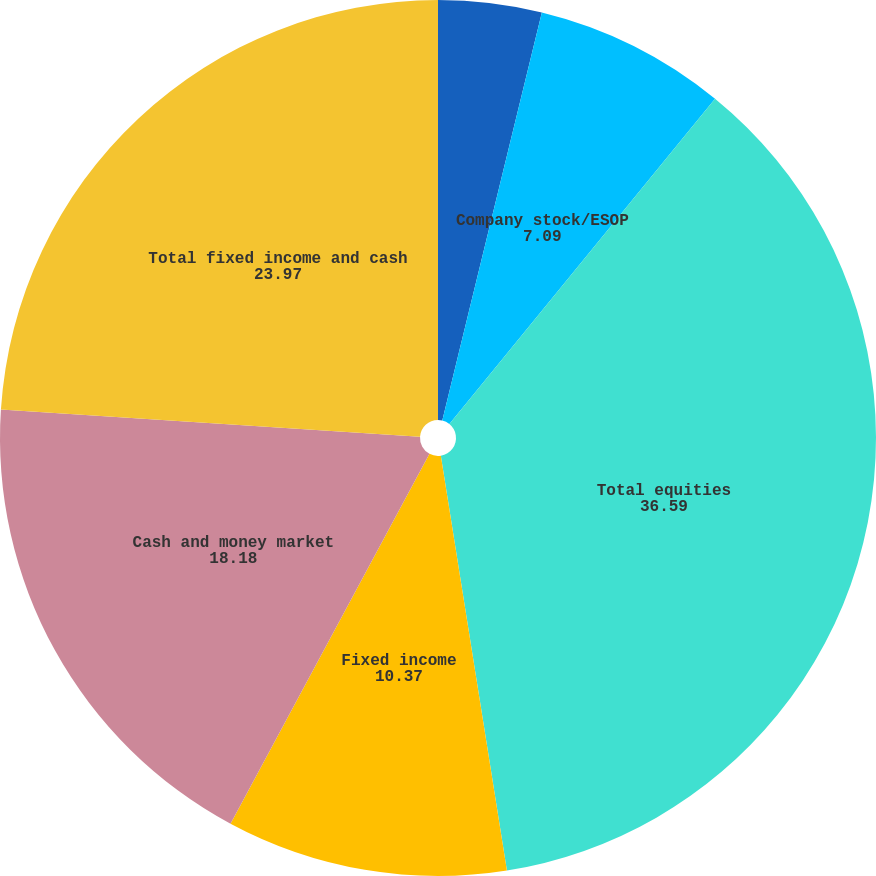<chart> <loc_0><loc_0><loc_500><loc_500><pie_chart><fcel>Active and other<fcel>Company stock/ESOP<fcel>Total equities<fcel>Fixed income<fcel>Cash and money market<fcel>Total fixed income and cash<nl><fcel>3.81%<fcel>7.09%<fcel>36.59%<fcel>10.37%<fcel>18.18%<fcel>23.97%<nl></chart> 